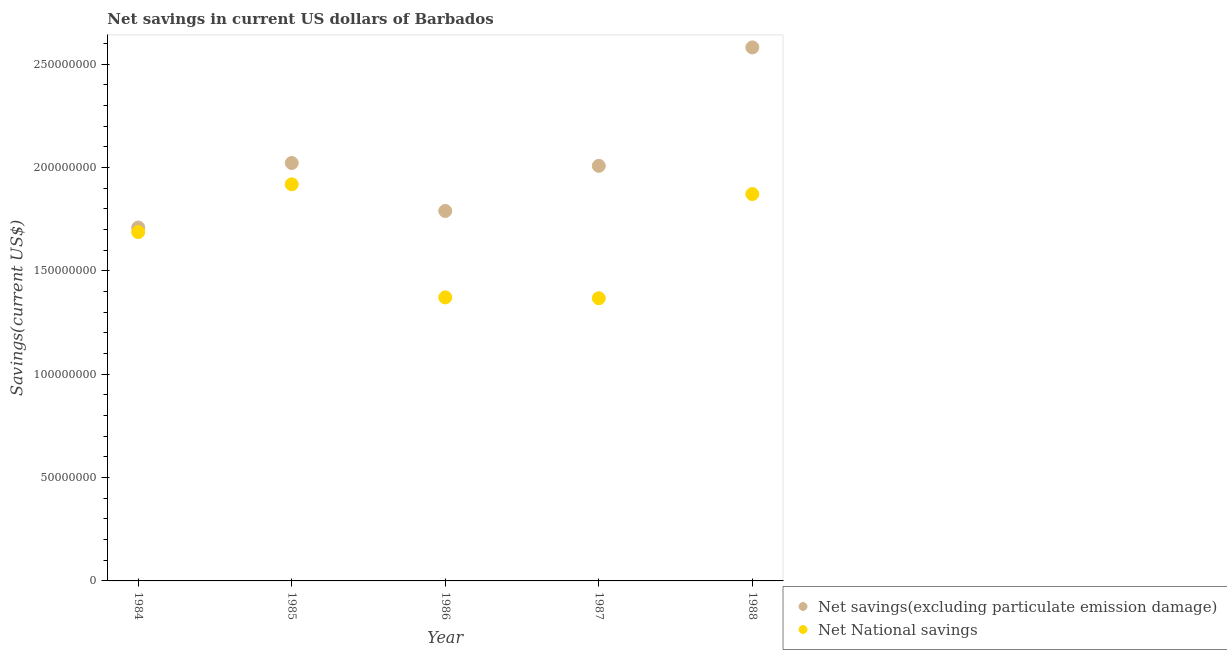How many different coloured dotlines are there?
Offer a terse response. 2. Is the number of dotlines equal to the number of legend labels?
Give a very brief answer. Yes. What is the net national savings in 1987?
Provide a succinct answer. 1.37e+08. Across all years, what is the maximum net national savings?
Your answer should be very brief. 1.92e+08. Across all years, what is the minimum net national savings?
Your response must be concise. 1.37e+08. In which year was the net savings(excluding particulate emission damage) maximum?
Provide a short and direct response. 1988. In which year was the net national savings minimum?
Keep it short and to the point. 1987. What is the total net savings(excluding particulate emission damage) in the graph?
Offer a very short reply. 1.01e+09. What is the difference between the net savings(excluding particulate emission damage) in 1985 and that in 1988?
Provide a short and direct response. -5.59e+07. What is the difference between the net national savings in 1988 and the net savings(excluding particulate emission damage) in 1986?
Keep it short and to the point. 8.17e+06. What is the average net national savings per year?
Your response must be concise. 1.64e+08. In the year 1984, what is the difference between the net savings(excluding particulate emission damage) and net national savings?
Your response must be concise. 2.23e+06. In how many years, is the net national savings greater than 190000000 US$?
Provide a succinct answer. 1. What is the ratio of the net national savings in 1984 to that in 1985?
Your answer should be compact. 0.88. What is the difference between the highest and the second highest net savings(excluding particulate emission damage)?
Offer a very short reply. 5.59e+07. What is the difference between the highest and the lowest net savings(excluding particulate emission damage)?
Offer a very short reply. 8.71e+07. Is the sum of the net savings(excluding particulate emission damage) in 1987 and 1988 greater than the maximum net national savings across all years?
Your answer should be very brief. Yes. Does the net national savings monotonically increase over the years?
Your response must be concise. No. How many dotlines are there?
Provide a short and direct response. 2. What is the difference between two consecutive major ticks on the Y-axis?
Ensure brevity in your answer.  5.00e+07. Are the values on the major ticks of Y-axis written in scientific E-notation?
Give a very brief answer. No. What is the title of the graph?
Your answer should be very brief. Net savings in current US dollars of Barbados. Does "Nitrous oxide emissions" appear as one of the legend labels in the graph?
Your response must be concise. No. What is the label or title of the Y-axis?
Make the answer very short. Savings(current US$). What is the Savings(current US$) of Net savings(excluding particulate emission damage) in 1984?
Your answer should be very brief. 1.71e+08. What is the Savings(current US$) of Net National savings in 1984?
Keep it short and to the point. 1.69e+08. What is the Savings(current US$) of Net savings(excluding particulate emission damage) in 1985?
Keep it short and to the point. 2.02e+08. What is the Savings(current US$) in Net National savings in 1985?
Keep it short and to the point. 1.92e+08. What is the Savings(current US$) of Net savings(excluding particulate emission damage) in 1986?
Offer a terse response. 1.79e+08. What is the Savings(current US$) of Net National savings in 1986?
Offer a terse response. 1.37e+08. What is the Savings(current US$) in Net savings(excluding particulate emission damage) in 1987?
Provide a succinct answer. 2.01e+08. What is the Savings(current US$) in Net National savings in 1987?
Make the answer very short. 1.37e+08. What is the Savings(current US$) in Net savings(excluding particulate emission damage) in 1988?
Keep it short and to the point. 2.58e+08. What is the Savings(current US$) of Net National savings in 1988?
Keep it short and to the point. 1.87e+08. Across all years, what is the maximum Savings(current US$) in Net savings(excluding particulate emission damage)?
Offer a terse response. 2.58e+08. Across all years, what is the maximum Savings(current US$) of Net National savings?
Give a very brief answer. 1.92e+08. Across all years, what is the minimum Savings(current US$) of Net savings(excluding particulate emission damage)?
Provide a succinct answer. 1.71e+08. Across all years, what is the minimum Savings(current US$) of Net National savings?
Your answer should be compact. 1.37e+08. What is the total Savings(current US$) of Net savings(excluding particulate emission damage) in the graph?
Your answer should be very brief. 1.01e+09. What is the total Savings(current US$) of Net National savings in the graph?
Offer a very short reply. 8.22e+08. What is the difference between the Savings(current US$) in Net savings(excluding particulate emission damage) in 1984 and that in 1985?
Provide a short and direct response. -3.12e+07. What is the difference between the Savings(current US$) of Net National savings in 1984 and that in 1985?
Ensure brevity in your answer.  -2.31e+07. What is the difference between the Savings(current US$) in Net savings(excluding particulate emission damage) in 1984 and that in 1986?
Your answer should be very brief. -8.00e+06. What is the difference between the Savings(current US$) of Net National savings in 1984 and that in 1986?
Provide a succinct answer. 3.16e+07. What is the difference between the Savings(current US$) in Net savings(excluding particulate emission damage) in 1984 and that in 1987?
Provide a short and direct response. -2.98e+07. What is the difference between the Savings(current US$) of Net National savings in 1984 and that in 1987?
Keep it short and to the point. 3.20e+07. What is the difference between the Savings(current US$) in Net savings(excluding particulate emission damage) in 1984 and that in 1988?
Provide a short and direct response. -8.71e+07. What is the difference between the Savings(current US$) of Net National savings in 1984 and that in 1988?
Your response must be concise. -1.84e+07. What is the difference between the Savings(current US$) in Net savings(excluding particulate emission damage) in 1985 and that in 1986?
Your answer should be compact. 2.32e+07. What is the difference between the Savings(current US$) of Net National savings in 1985 and that in 1986?
Ensure brevity in your answer.  5.47e+07. What is the difference between the Savings(current US$) in Net savings(excluding particulate emission damage) in 1985 and that in 1987?
Ensure brevity in your answer.  1.39e+06. What is the difference between the Savings(current US$) of Net National savings in 1985 and that in 1987?
Your answer should be compact. 5.51e+07. What is the difference between the Savings(current US$) of Net savings(excluding particulate emission damage) in 1985 and that in 1988?
Ensure brevity in your answer.  -5.59e+07. What is the difference between the Savings(current US$) of Net National savings in 1985 and that in 1988?
Provide a short and direct response. 4.72e+06. What is the difference between the Savings(current US$) of Net savings(excluding particulate emission damage) in 1986 and that in 1987?
Make the answer very short. -2.18e+07. What is the difference between the Savings(current US$) of Net National savings in 1986 and that in 1987?
Keep it short and to the point. 4.00e+05. What is the difference between the Savings(current US$) in Net savings(excluding particulate emission damage) in 1986 and that in 1988?
Offer a terse response. -7.91e+07. What is the difference between the Savings(current US$) of Net National savings in 1986 and that in 1988?
Keep it short and to the point. -5.00e+07. What is the difference between the Savings(current US$) of Net savings(excluding particulate emission damage) in 1987 and that in 1988?
Your response must be concise. -5.73e+07. What is the difference between the Savings(current US$) in Net National savings in 1987 and that in 1988?
Offer a terse response. -5.04e+07. What is the difference between the Savings(current US$) in Net savings(excluding particulate emission damage) in 1984 and the Savings(current US$) in Net National savings in 1985?
Your answer should be very brief. -2.09e+07. What is the difference between the Savings(current US$) in Net savings(excluding particulate emission damage) in 1984 and the Savings(current US$) in Net National savings in 1986?
Ensure brevity in your answer.  3.38e+07. What is the difference between the Savings(current US$) in Net savings(excluding particulate emission damage) in 1984 and the Savings(current US$) in Net National savings in 1987?
Offer a very short reply. 3.42e+07. What is the difference between the Savings(current US$) in Net savings(excluding particulate emission damage) in 1984 and the Savings(current US$) in Net National savings in 1988?
Make the answer very short. -1.62e+07. What is the difference between the Savings(current US$) in Net savings(excluding particulate emission damage) in 1985 and the Savings(current US$) in Net National savings in 1986?
Offer a very short reply. 6.50e+07. What is the difference between the Savings(current US$) in Net savings(excluding particulate emission damage) in 1985 and the Savings(current US$) in Net National savings in 1987?
Provide a succinct answer. 6.54e+07. What is the difference between the Savings(current US$) of Net savings(excluding particulate emission damage) in 1985 and the Savings(current US$) of Net National savings in 1988?
Offer a terse response. 1.50e+07. What is the difference between the Savings(current US$) in Net savings(excluding particulate emission damage) in 1986 and the Savings(current US$) in Net National savings in 1987?
Make the answer very short. 4.22e+07. What is the difference between the Savings(current US$) in Net savings(excluding particulate emission damage) in 1986 and the Savings(current US$) in Net National savings in 1988?
Your answer should be compact. -8.17e+06. What is the difference between the Savings(current US$) in Net savings(excluding particulate emission damage) in 1987 and the Savings(current US$) in Net National savings in 1988?
Give a very brief answer. 1.37e+07. What is the average Savings(current US$) in Net savings(excluding particulate emission damage) per year?
Your answer should be very brief. 2.02e+08. What is the average Savings(current US$) of Net National savings per year?
Make the answer very short. 1.64e+08. In the year 1984, what is the difference between the Savings(current US$) in Net savings(excluding particulate emission damage) and Savings(current US$) in Net National savings?
Keep it short and to the point. 2.23e+06. In the year 1985, what is the difference between the Savings(current US$) of Net savings(excluding particulate emission damage) and Savings(current US$) of Net National savings?
Keep it short and to the point. 1.03e+07. In the year 1986, what is the difference between the Savings(current US$) in Net savings(excluding particulate emission damage) and Savings(current US$) in Net National savings?
Your answer should be very brief. 4.18e+07. In the year 1987, what is the difference between the Savings(current US$) in Net savings(excluding particulate emission damage) and Savings(current US$) in Net National savings?
Your response must be concise. 6.40e+07. In the year 1988, what is the difference between the Savings(current US$) in Net savings(excluding particulate emission damage) and Savings(current US$) in Net National savings?
Your response must be concise. 7.10e+07. What is the ratio of the Savings(current US$) of Net savings(excluding particulate emission damage) in 1984 to that in 1985?
Keep it short and to the point. 0.85. What is the ratio of the Savings(current US$) of Net National savings in 1984 to that in 1985?
Keep it short and to the point. 0.88. What is the ratio of the Savings(current US$) in Net savings(excluding particulate emission damage) in 1984 to that in 1986?
Offer a very short reply. 0.96. What is the ratio of the Savings(current US$) in Net National savings in 1984 to that in 1986?
Keep it short and to the point. 1.23. What is the ratio of the Savings(current US$) in Net savings(excluding particulate emission damage) in 1984 to that in 1987?
Your answer should be compact. 0.85. What is the ratio of the Savings(current US$) in Net National savings in 1984 to that in 1987?
Offer a very short reply. 1.23. What is the ratio of the Savings(current US$) of Net savings(excluding particulate emission damage) in 1984 to that in 1988?
Your response must be concise. 0.66. What is the ratio of the Savings(current US$) in Net National savings in 1984 to that in 1988?
Keep it short and to the point. 0.9. What is the ratio of the Savings(current US$) of Net savings(excluding particulate emission damage) in 1985 to that in 1986?
Your answer should be compact. 1.13. What is the ratio of the Savings(current US$) of Net National savings in 1985 to that in 1986?
Your response must be concise. 1.4. What is the ratio of the Savings(current US$) in Net National savings in 1985 to that in 1987?
Give a very brief answer. 1.4. What is the ratio of the Savings(current US$) in Net savings(excluding particulate emission damage) in 1985 to that in 1988?
Provide a succinct answer. 0.78. What is the ratio of the Savings(current US$) of Net National savings in 1985 to that in 1988?
Provide a succinct answer. 1.03. What is the ratio of the Savings(current US$) in Net savings(excluding particulate emission damage) in 1986 to that in 1987?
Ensure brevity in your answer.  0.89. What is the ratio of the Savings(current US$) of Net National savings in 1986 to that in 1987?
Make the answer very short. 1. What is the ratio of the Savings(current US$) of Net savings(excluding particulate emission damage) in 1986 to that in 1988?
Give a very brief answer. 0.69. What is the ratio of the Savings(current US$) in Net National savings in 1986 to that in 1988?
Ensure brevity in your answer.  0.73. What is the ratio of the Savings(current US$) in Net savings(excluding particulate emission damage) in 1987 to that in 1988?
Offer a very short reply. 0.78. What is the ratio of the Savings(current US$) of Net National savings in 1987 to that in 1988?
Your answer should be very brief. 0.73. What is the difference between the highest and the second highest Savings(current US$) in Net savings(excluding particulate emission damage)?
Offer a terse response. 5.59e+07. What is the difference between the highest and the second highest Savings(current US$) of Net National savings?
Make the answer very short. 4.72e+06. What is the difference between the highest and the lowest Savings(current US$) in Net savings(excluding particulate emission damage)?
Ensure brevity in your answer.  8.71e+07. What is the difference between the highest and the lowest Savings(current US$) in Net National savings?
Give a very brief answer. 5.51e+07. 